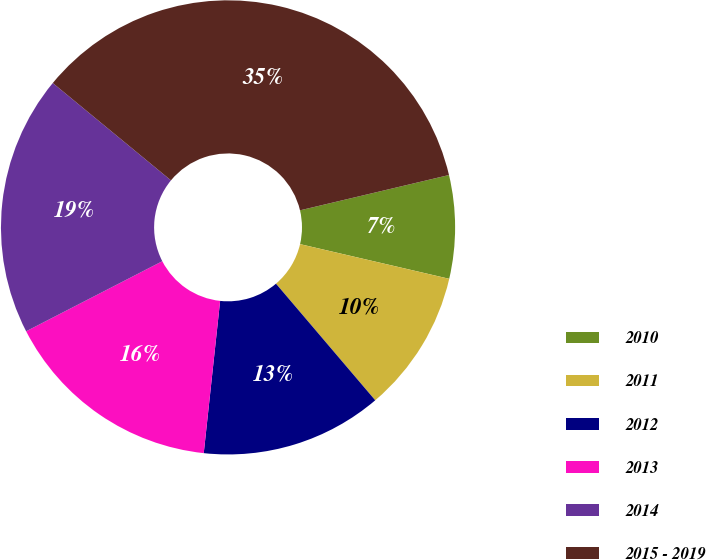Convert chart. <chart><loc_0><loc_0><loc_500><loc_500><pie_chart><fcel>2010<fcel>2011<fcel>2012<fcel>2013<fcel>2014<fcel>2015 - 2019<nl><fcel>7.34%<fcel>10.14%<fcel>12.93%<fcel>15.73%<fcel>18.53%<fcel>35.33%<nl></chart> 